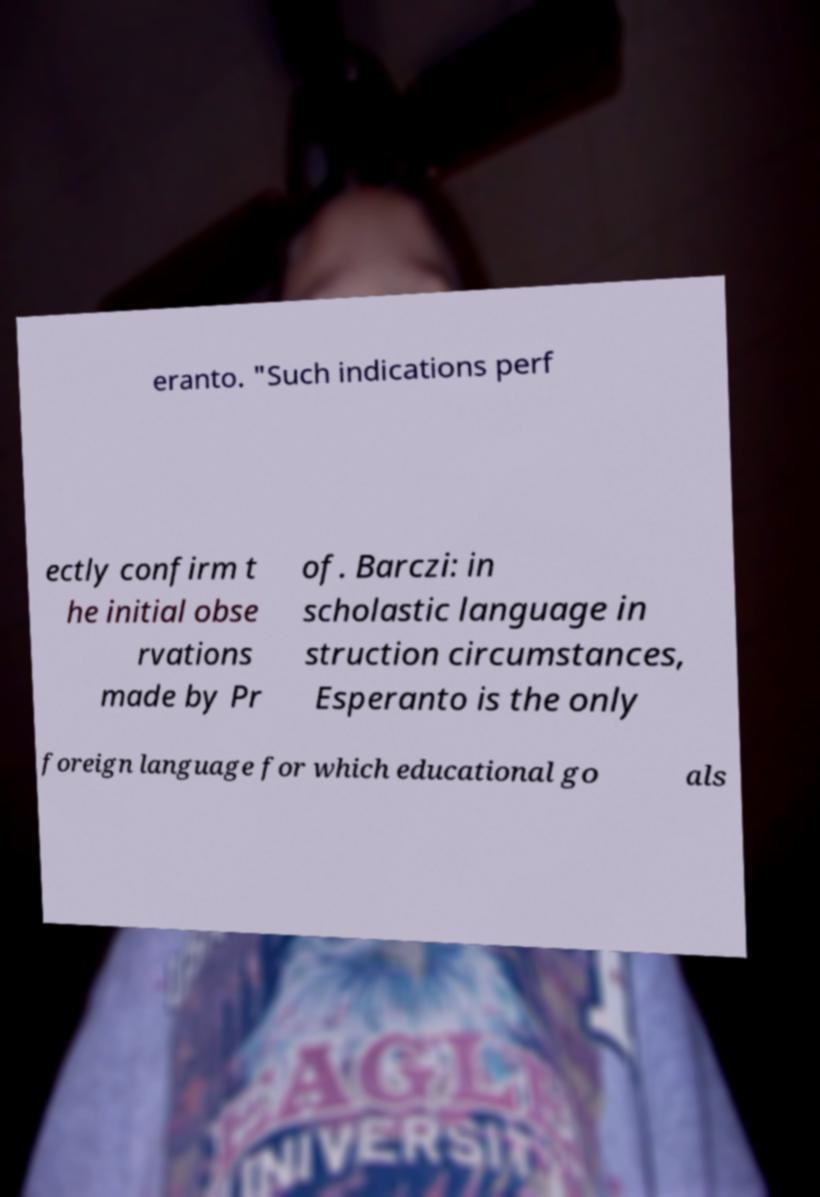For documentation purposes, I need the text within this image transcribed. Could you provide that? eranto. "Such indications perf ectly confirm t he initial obse rvations made by Pr of. Barczi: in scholastic language in struction circumstances, Esperanto is the only foreign language for which educational go als 